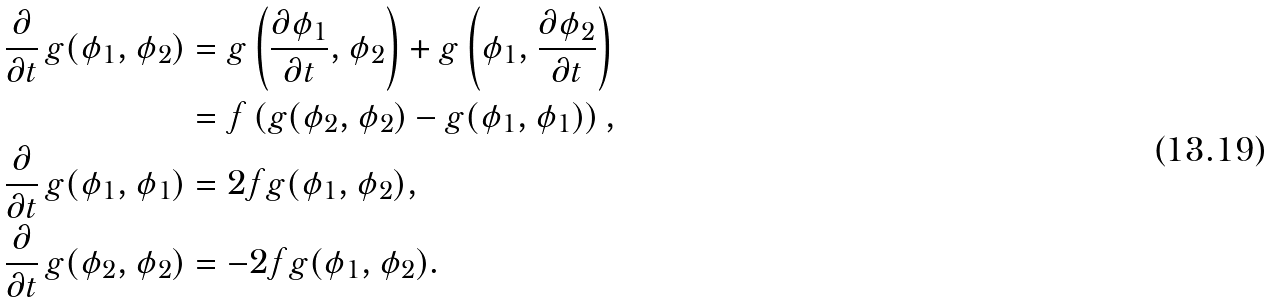<formula> <loc_0><loc_0><loc_500><loc_500>\frac { \partial } { \partial t } \, g ( \phi _ { 1 } , \phi _ { 2 } ) & = g \left ( \frac { \partial \phi _ { 1 } } { \partial t } , \phi _ { 2 } \right ) + g \left ( \phi _ { 1 } , \frac { \partial \phi _ { 2 } } { \partial t } \right ) \\ & = f \left ( g ( \phi _ { 2 } , \phi _ { 2 } ) - g ( \phi _ { 1 } , \phi _ { 1 } ) \right ) , \\ \frac { \partial } { \partial t } \, g ( \phi _ { 1 } , \phi _ { 1 } ) & = 2 f g ( \phi _ { 1 } , \phi _ { 2 } ) , \\ \frac { \partial } { \partial t } \, g ( \phi _ { 2 } , \phi _ { 2 } ) & = - 2 f g ( \phi _ { 1 } , \phi _ { 2 } ) .</formula> 